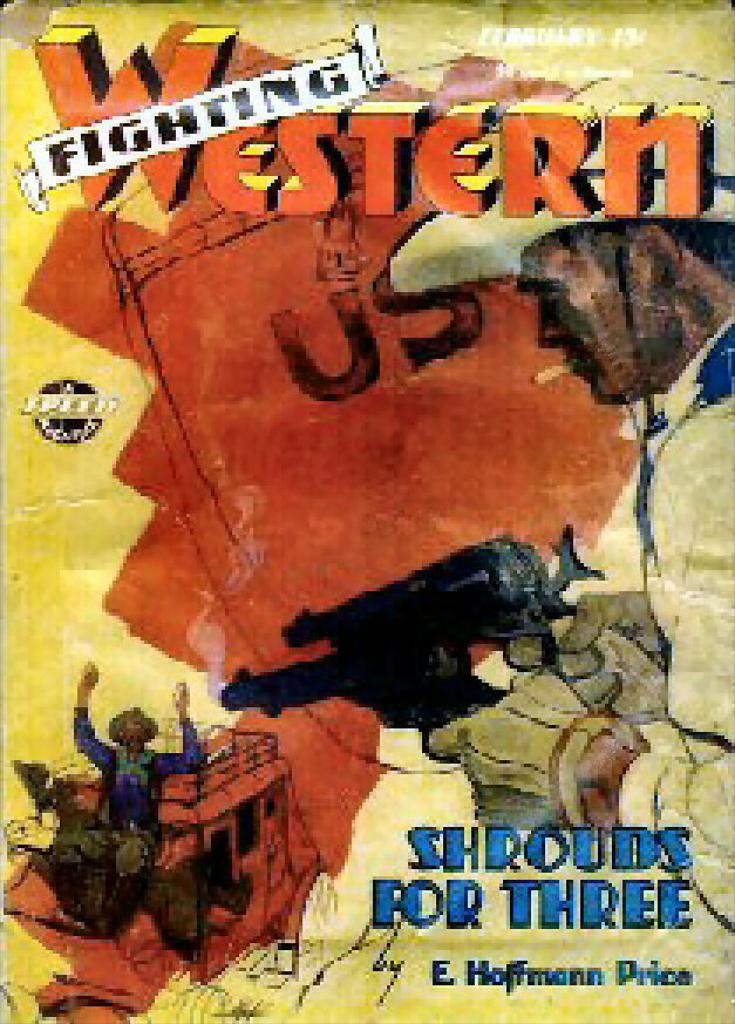<image>
Offer a succinct explanation of the picture presented. An advertisement for Shrouds for Three from Fighting Western. 